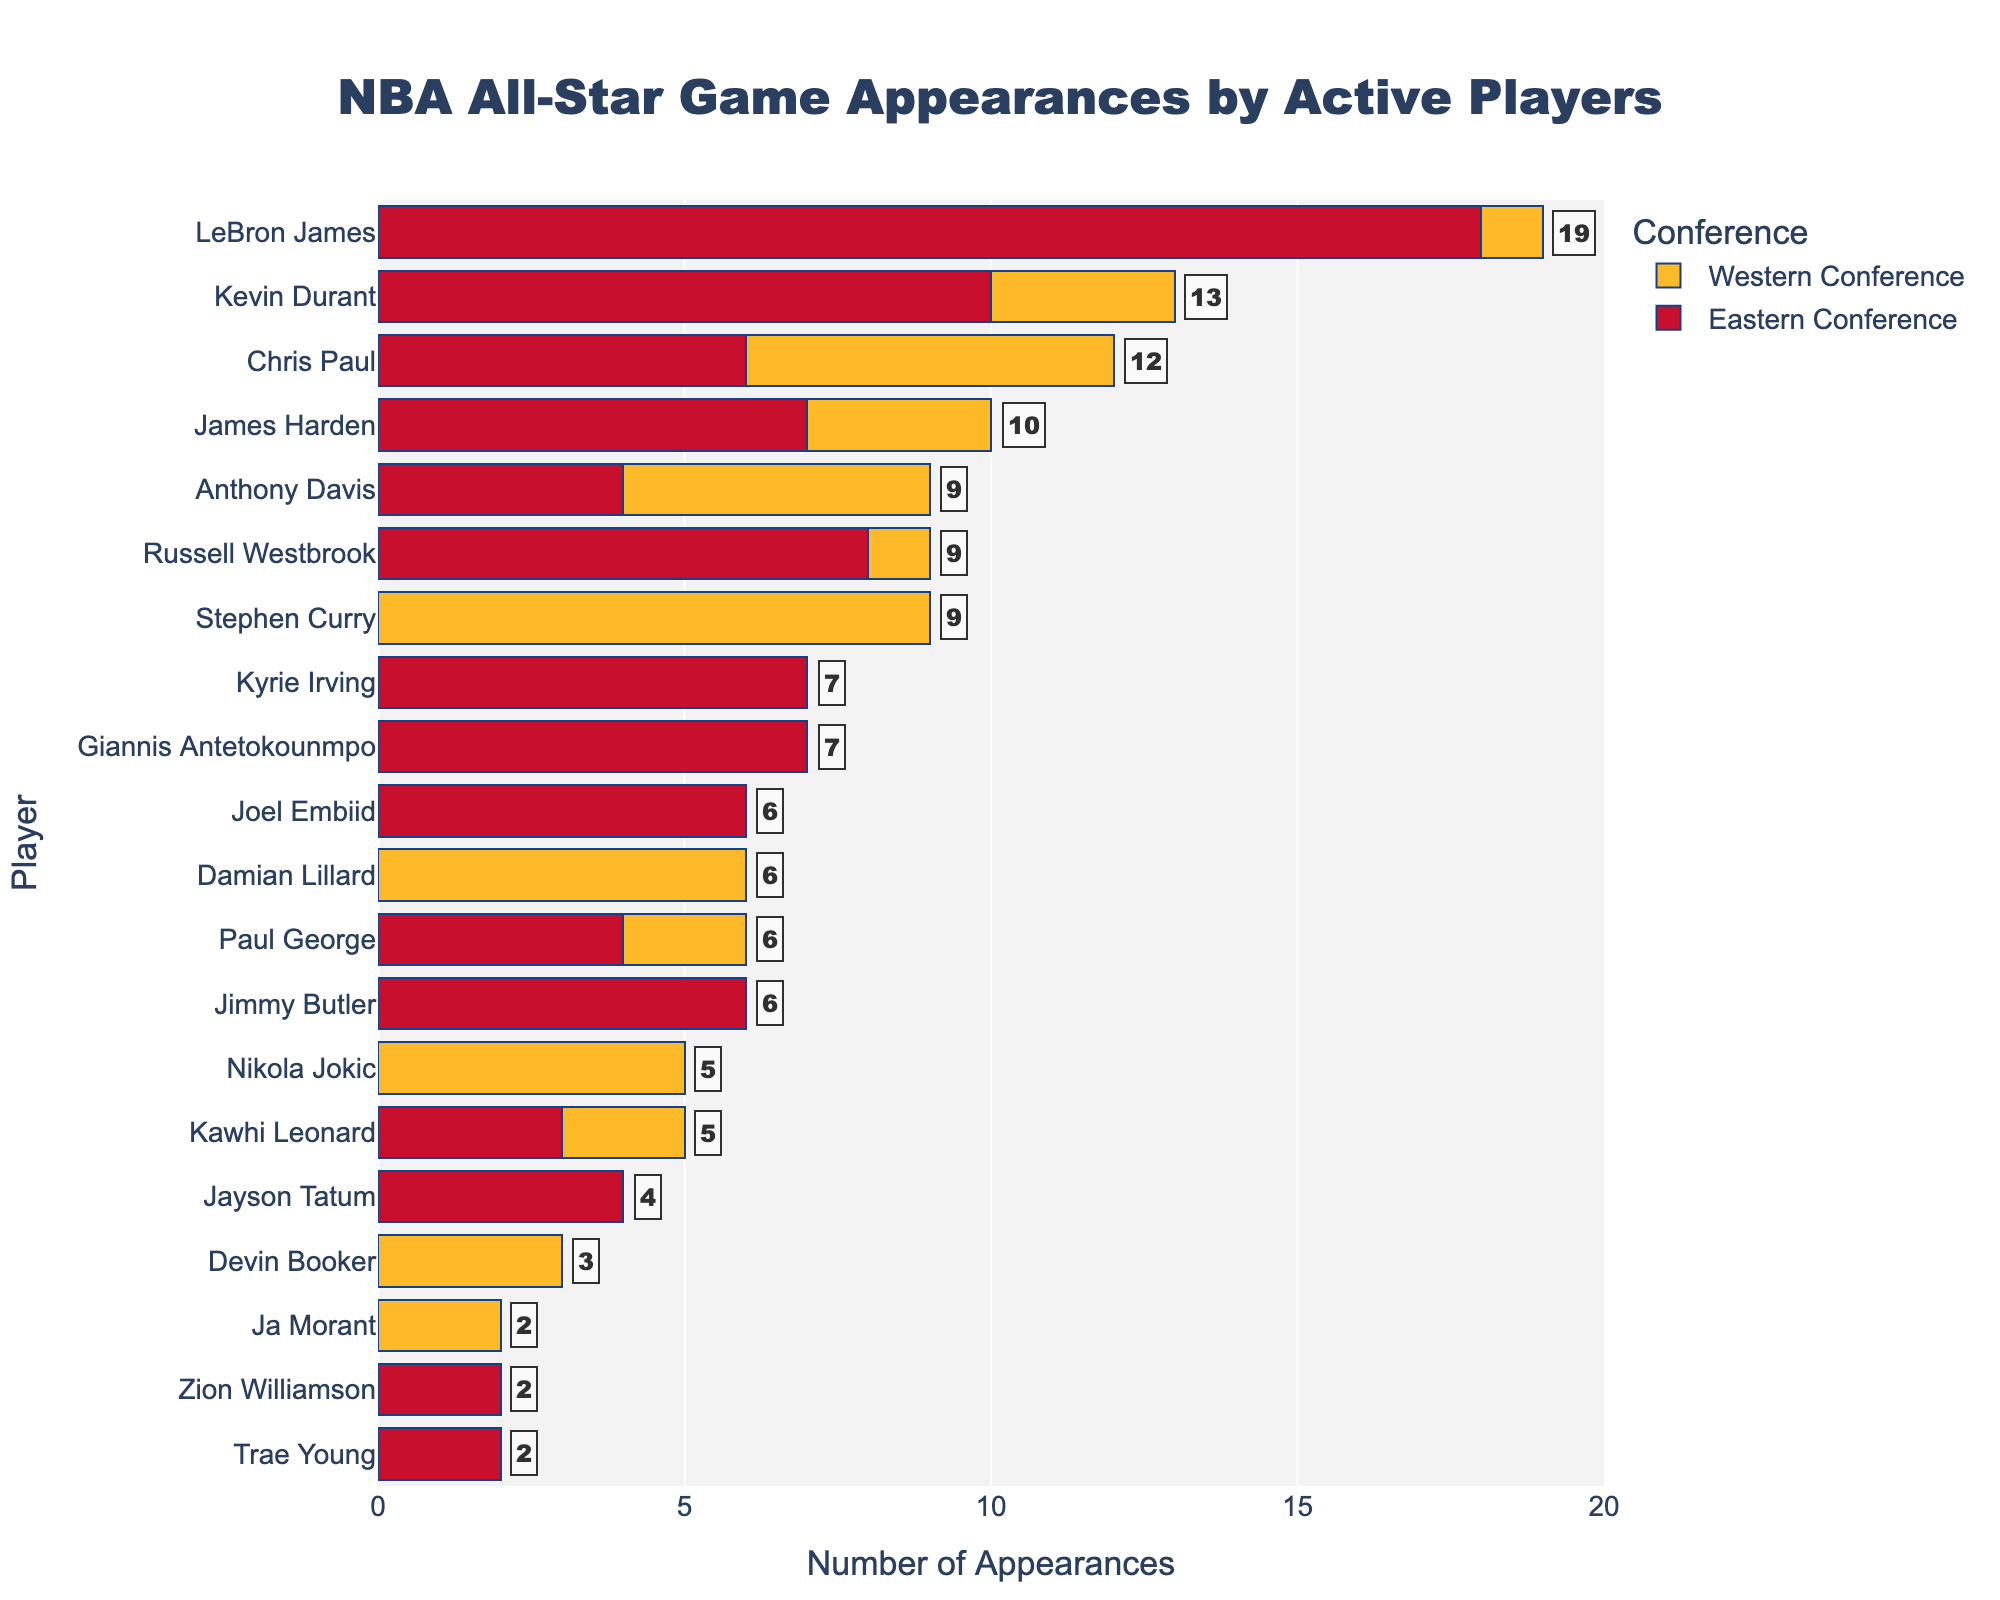Which player has the most NBA All-Star appearances? Looking at the bar chart, LeBron James has the tallest combined bar for Eastern and Western Conference appearances, which confirms he has the most NBA All-Star appearances.
Answer: LeBron James How many total NBA All-Star appearances does Kevin Durant have? Kevin Durant's bars indicate 10 appearances in the Eastern Conference and 3 in the Western Conference. Summing these two values gives his total appearances.
Answer: 13 Who has more Western Conference All-Star appearances: Stephen Curry or Damian Lillard? Comparing the height of the yellow bars, Stephen Curry's Western Conference bar is longer than Damian Lillard’s bar.
Answer: Stephen Curry What is the difference in total All-Star appearances between James Harden and Chris Paul? James Harden has a total of 10 (7 in Eastern and 3 in Western) while Chris Paul has 12 (6 in Eastern and 6 in Western). Subtracting these totals gives the difference.
Answer: 2 What is the sum of Eastern Conference All-Star appearances for Joel Embiid and Jayson Tatum? Joel Embiid has 6 and Jayson Tatum has 4 Eastern Conference appearances. Adding these values gives the sum.
Answer: 10 Which player with appearances in both conferences has the fewest total All-Star appearances? Analyzing players with non-zero bars in both Eastern and Western Conferences, Kawhi Leonard has the shortest combined bar with 5 appearances overall (3 in Eastern and 2 in Western).
Answer: Kawhi Leonard How many total All-Star appearances are represented in the Western Conference for all players combined? Summing up the Western Conference bars for all players: LeBron James (1), Kevin Durant (3), Stephen Curry (9), James Harden (3), Chris Paul (6), Russell Westbrook (1), Kawhi Leonard (2), Anthony Davis (5), Paul George (2), Nikola Jokic (5), Devin Booker (3), Ja Morant (2). Total is 42.
Answer: 42 Which player in the Eastern Conference has as many appearances as Russell Westbrook in the Western Conference? Russell Westbrook has 1 appearance in the Western Conference. From the chart, no player in the Eastern Conference has only 1 appearance as all such players have more.
Answer: None 